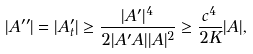<formula> <loc_0><loc_0><loc_500><loc_500>| A ^ { \prime \prime } | = | A ^ { \prime } _ { t } | \geq \frac { | A ^ { \prime } | ^ { 4 } } { 2 | A ^ { \prime } A | | A | ^ { 2 } } \geq \frac { c ^ { 4 } } { 2 K } | A | ,</formula> 